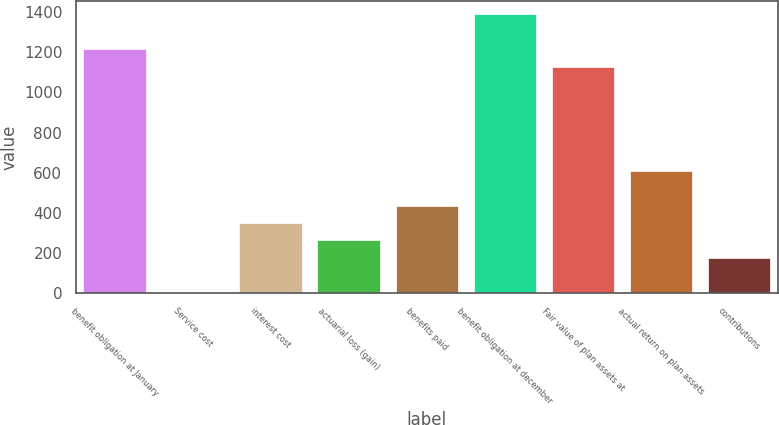Convert chart to OTSL. <chart><loc_0><loc_0><loc_500><loc_500><bar_chart><fcel>benefit obligation at January<fcel>Service cost<fcel>interest cost<fcel>actuarial loss (gain)<fcel>benefits paid<fcel>benefit obligation at december<fcel>Fair value of plan assets at<fcel>actual return on plan assets<fcel>contributions<nl><fcel>1214.52<fcel>3.8<fcel>349.72<fcel>263.24<fcel>436.2<fcel>1387.48<fcel>1128.04<fcel>609.16<fcel>176.76<nl></chart> 